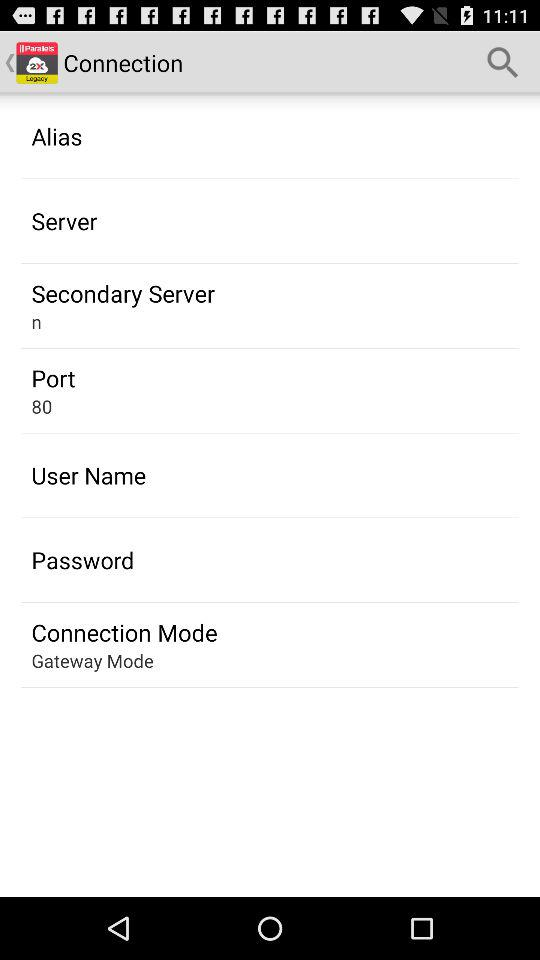What is the port number? The port number is 80. 